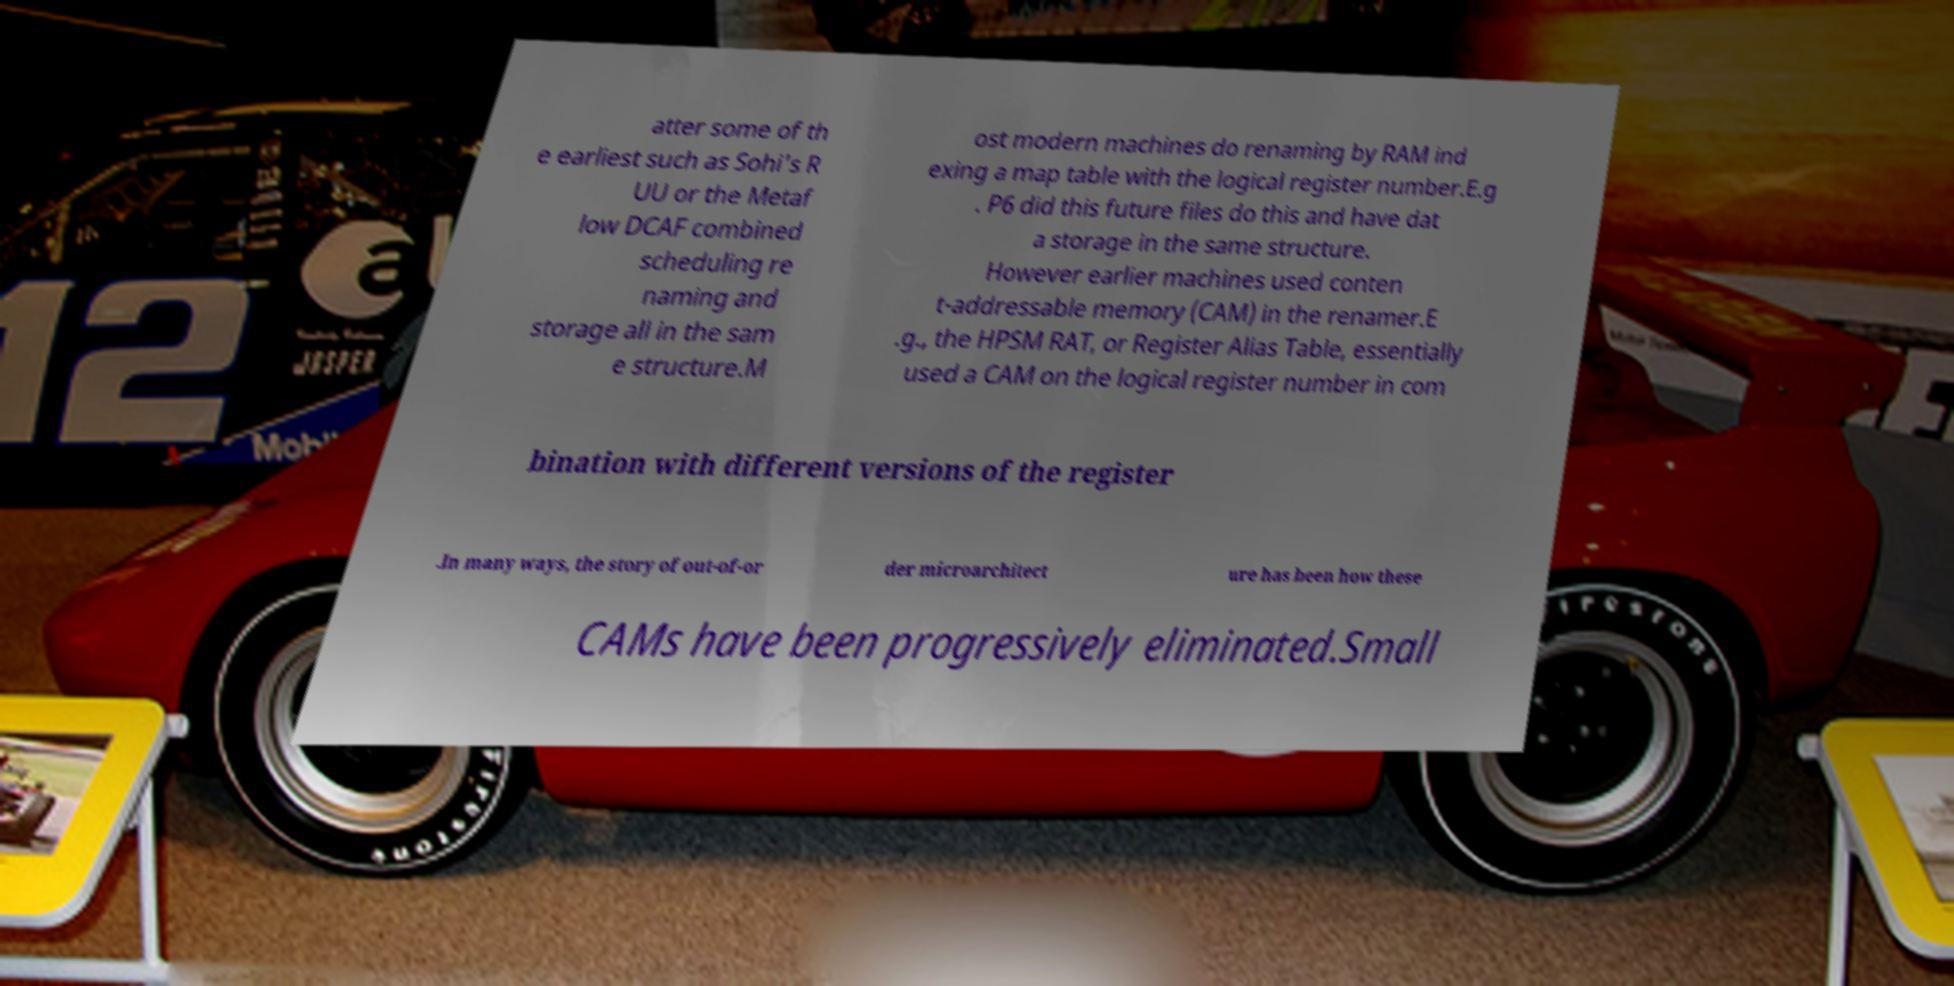For documentation purposes, I need the text within this image transcribed. Could you provide that? atter some of th e earliest such as Sohi's R UU or the Metaf low DCAF combined scheduling re naming and storage all in the sam e structure.M ost modern machines do renaming by RAM ind exing a map table with the logical register number.E.g . P6 did this future files do this and have dat a storage in the same structure. However earlier machines used conten t-addressable memory (CAM) in the renamer.E .g., the HPSM RAT, or Register Alias Table, essentially used a CAM on the logical register number in com bination with different versions of the register .In many ways, the story of out-of-or der microarchitect ure has been how these CAMs have been progressively eliminated.Small 